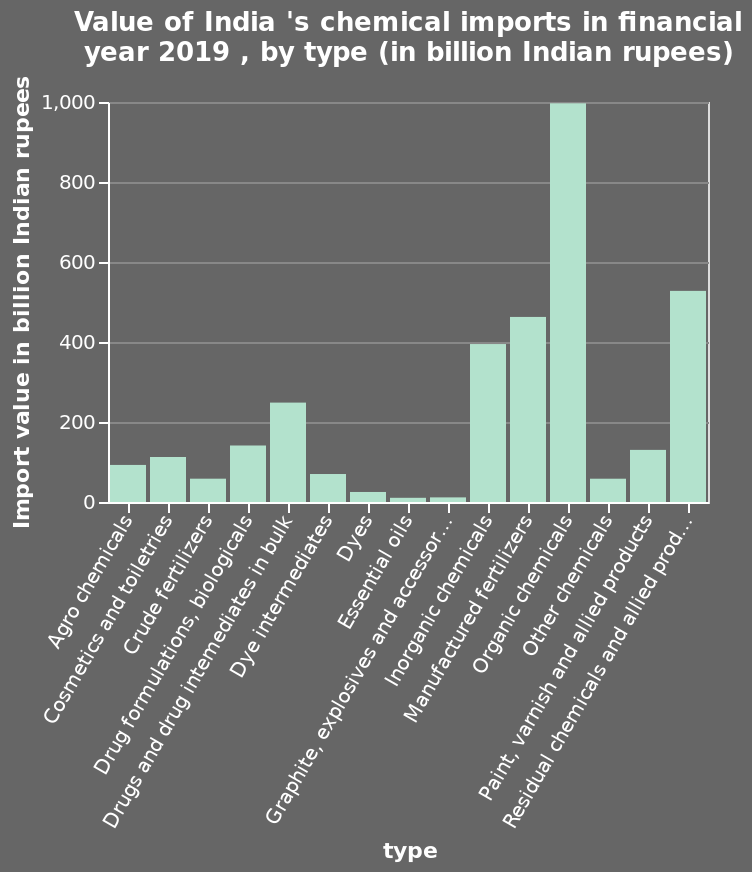<image>
What is the name of the bar plot and what does it represent? The bar plot is named "Value of India's chemical imports in financial year 2019, by type (in billion Indian rupees)". It represents the import value of different types of chemicals in India in billion Indian rupees. What are the least valuable imports?  Essential oils, graphite, explosives, and accessors. What is shown along the y-axis of the bar plot and what is its range? Along the y-axis of the bar plot, the import value in billion Indian rupees is shown. The range of the y-axis is from 0 to 1,000. please summary the statistics and relations of the chart Organic chemicals are the most valuable import. Essential oils, graphite, explosives and accessors are the least valuable. Does the bar plot represent the import value of different types of chemicals in India in billion Indian rupees? No.The bar plot is named "Value of India's chemical imports in financial year 2019, by type (in billion Indian rupees)". It represents the import value of different types of chemicals in India in billion Indian rupees. 